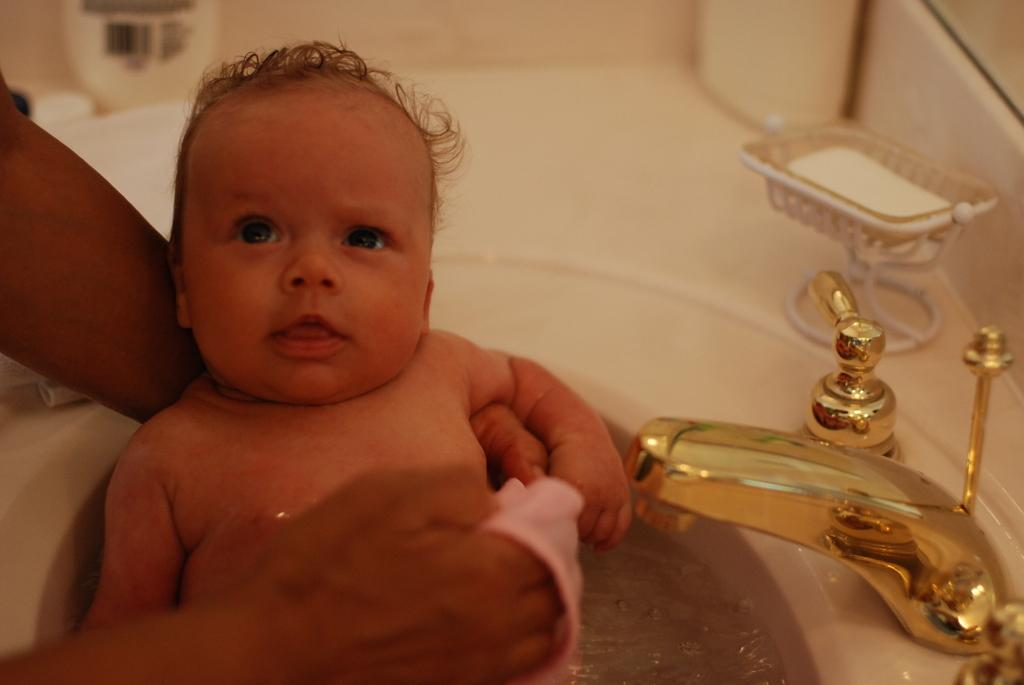What is the person in the image doing with the baby? The person is holding a baby in the image. How is the person holding the baby? The person is holding the baby with their hands. What can be seen near the person and baby? There is a tap and soap in the image. What else is present in the image? There are bottles in the image. What is visible in the background of the image? There is a wall in the background of the image. What type of humor can be seen in the image? There is no humor present in the image; it depicts a person holding a baby. What type of spoon is being used by the person in the image? There is no spoon present in the image. 